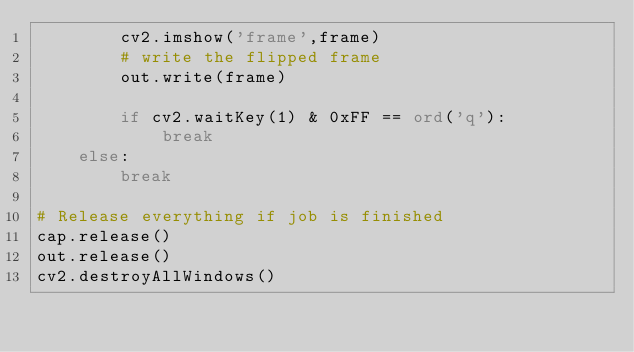Convert code to text. <code><loc_0><loc_0><loc_500><loc_500><_Python_>        cv2.imshow('frame',frame)
        # write the flipped frame
        out.write(frame)

        if cv2.waitKey(1) & 0xFF == ord('q'):
            break
    else:
        break

# Release everything if job is finished
cap.release()
out.release()
cv2.destroyAllWindows()</code> 